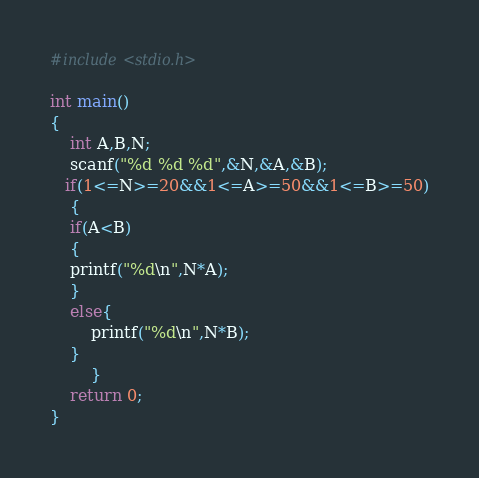Convert code to text. <code><loc_0><loc_0><loc_500><loc_500><_C_>#include<stdio.h>

int main()
{
    int A,B,N;
    scanf("%d %d %d",&N,&A,&B);
   if(1<=N>=20&&1<=A>=50&&1<=B>=50)
    {
    if(A<B)
    {
    printf("%d\n",N*A);
    }
    else{
        printf("%d\n",N*B);
    }
        }
    return 0;
}</code> 